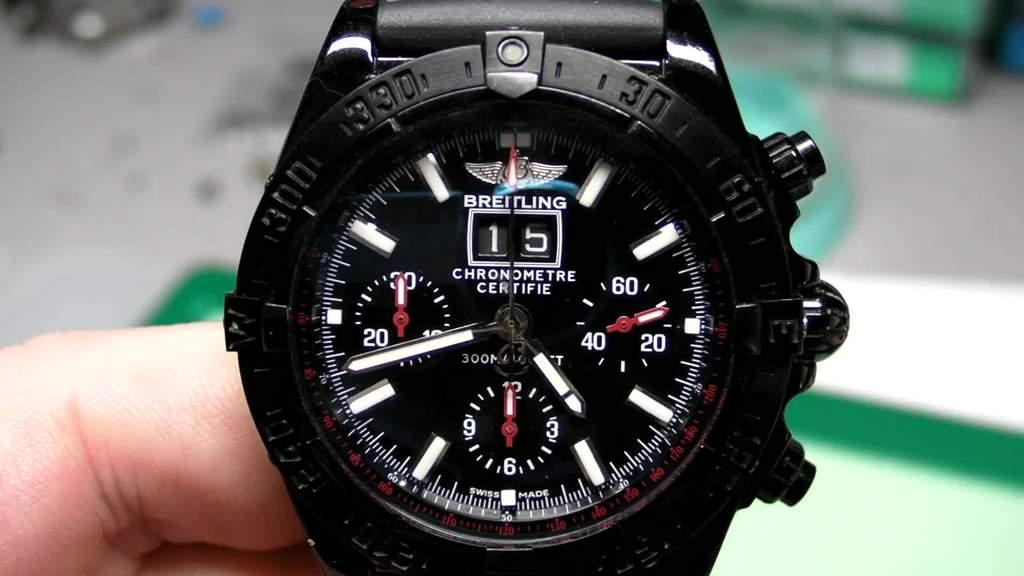<image>
Create a compact narrative representing the image presented. A person shows off their multi-functional watch and chronometer. 